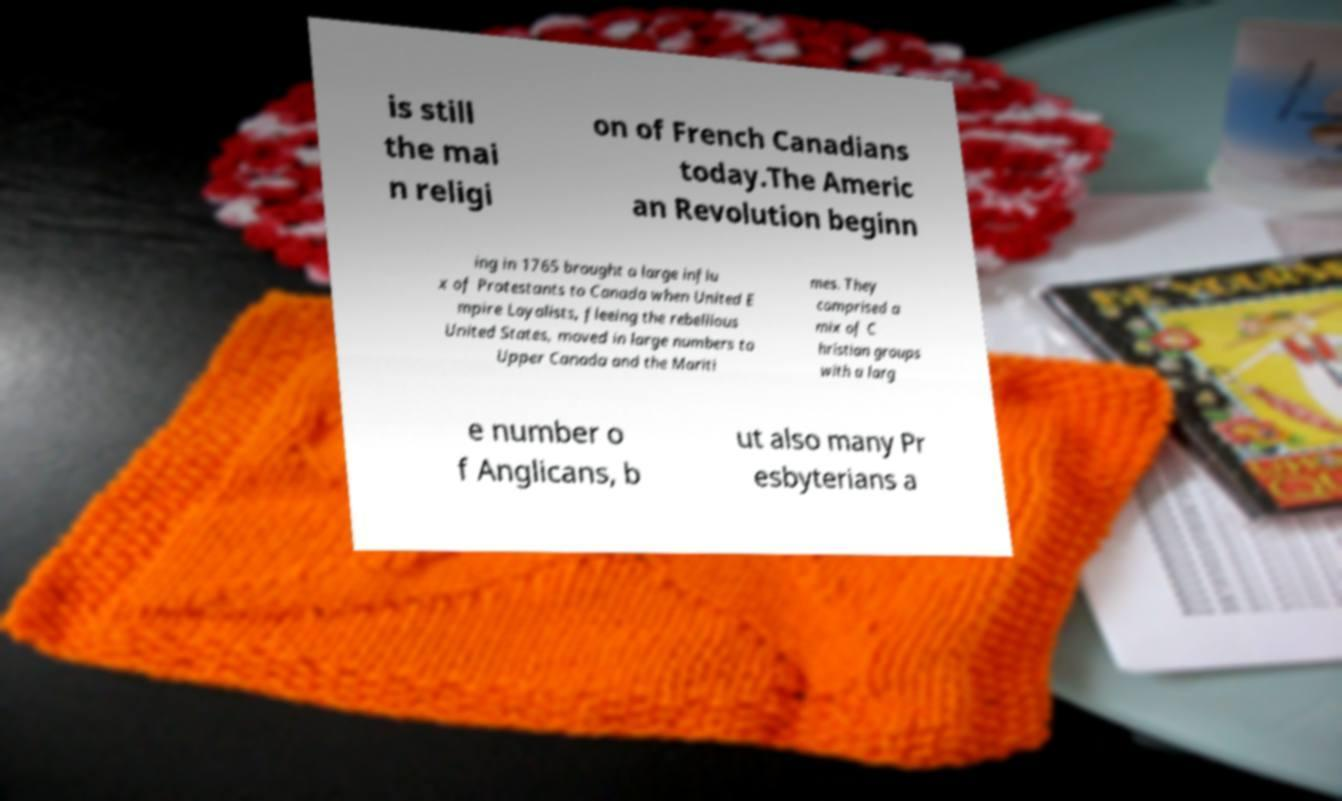For documentation purposes, I need the text within this image transcribed. Could you provide that? is still the mai n religi on of French Canadians today.The Americ an Revolution beginn ing in 1765 brought a large influ x of Protestants to Canada when United E mpire Loyalists, fleeing the rebellious United States, moved in large numbers to Upper Canada and the Mariti mes. They comprised a mix of C hristian groups with a larg e number o f Anglicans, b ut also many Pr esbyterians a 